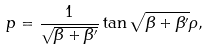<formula> <loc_0><loc_0><loc_500><loc_500>p = \frac { 1 } { \sqrt { \beta + \beta ^ { \prime } } } \tan \sqrt { \beta + \beta ^ { \prime } } \rho ,</formula> 